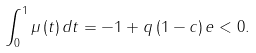Convert formula to latex. <formula><loc_0><loc_0><loc_500><loc_500>\int _ { 0 } ^ { 1 } \mu \left ( t \right ) d t = - 1 + q \left ( 1 - c \right ) e < 0 .</formula> 